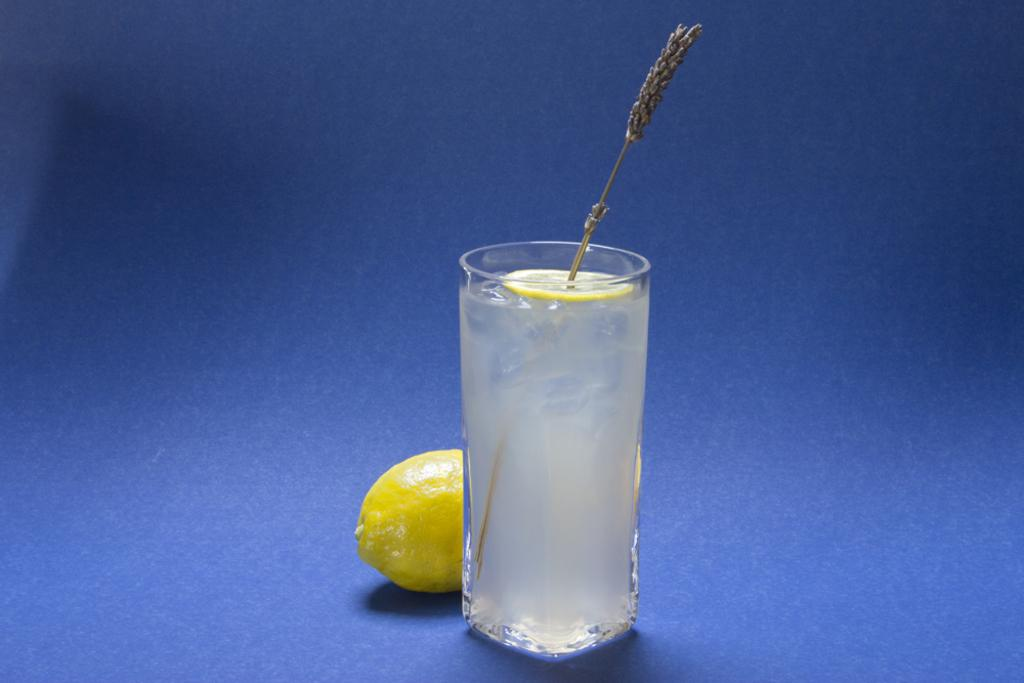What color is the surface in the image? The surface in the image is blue. What is placed on the blue surface? There is a glass with a drink on the blue surface. What can be seen inside the glass? There is a lemon slice with a stick inside the glass. Is there anything else related to lemons in the image? Yes, there is a lemon behind the glass. What type of ball is being used to destroy the lemon in the image? There is no ball or destruction present in the image; it features a glass with a lemon slice and a lemon behind it. What type of skin is visible on the lemon in the image? The image does not show the skin of the lemon; it only shows the lemon slice inside the glass and the whole lemon behind the glass. 